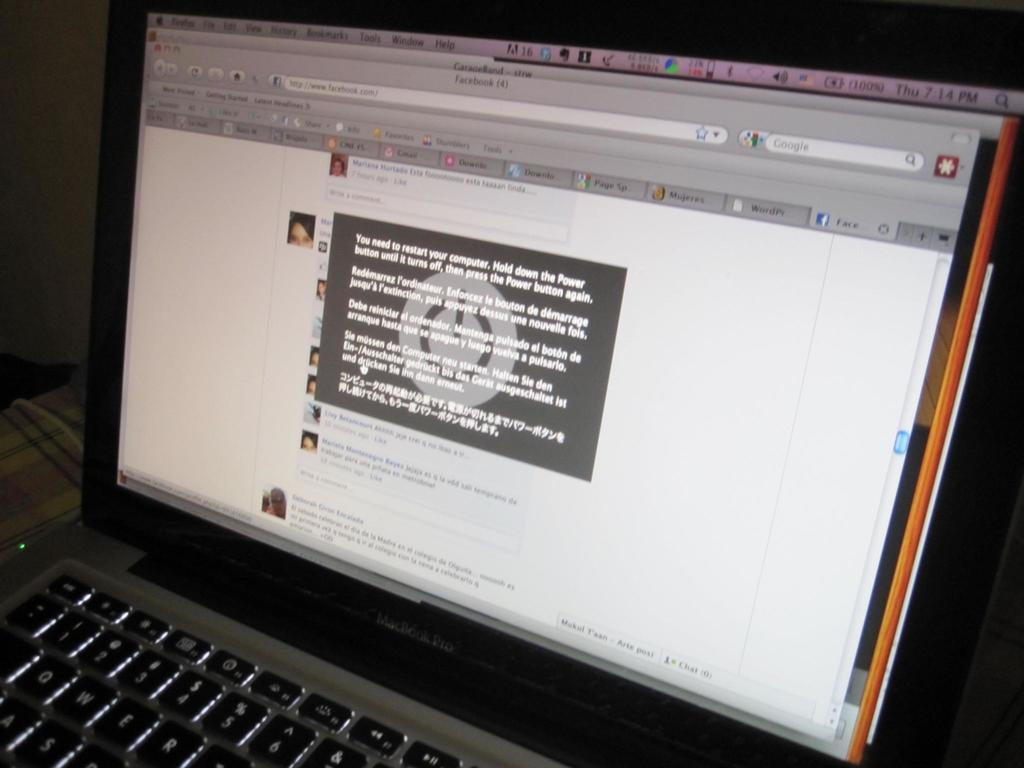What electronic device is visible in the image? There is a laptop in the image. What is displayed on the laptop screen? The laptop screen displays a page with words. Can you describe the background of the image? The background of the image is dark. What type of honey is being poured into the soda in the image? There is no honey or soda present in the image; it only features a laptop with a dark background. 